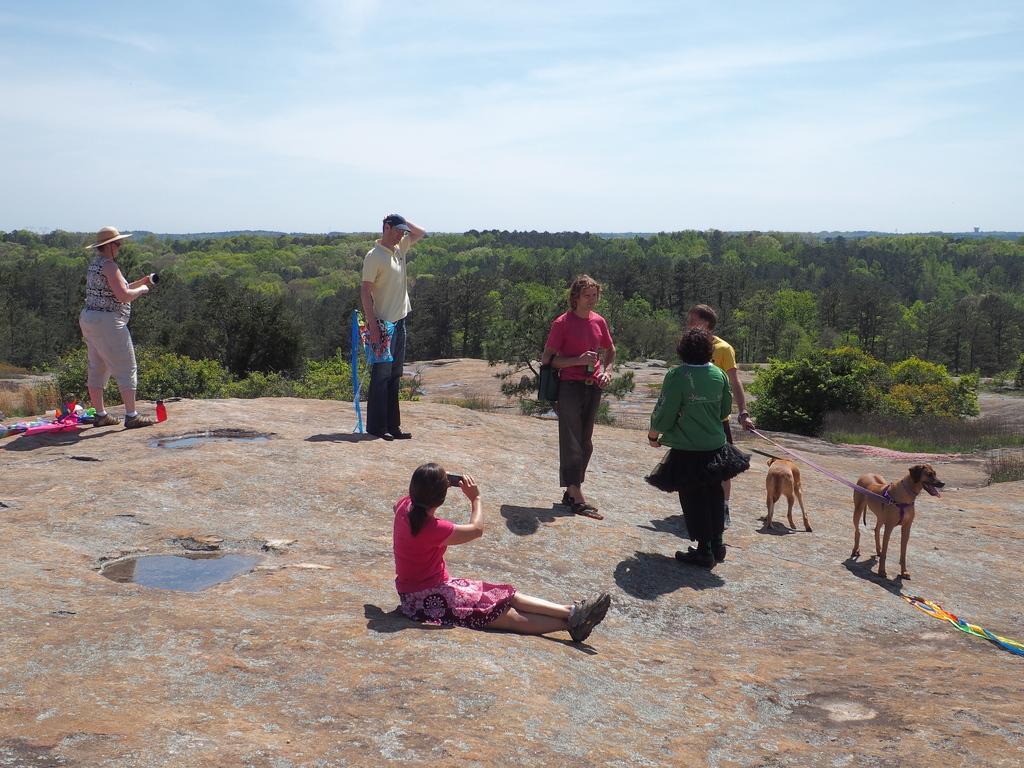Can you describe this image briefly? In the picture we can see a rock surface on it, we can see some people are standing and one woman is sitting and capturing their pictures with a camera and one person is holding dogs with belts and behind them, we can see some plants and full of trees and behind it we can see a sky with clouds. 